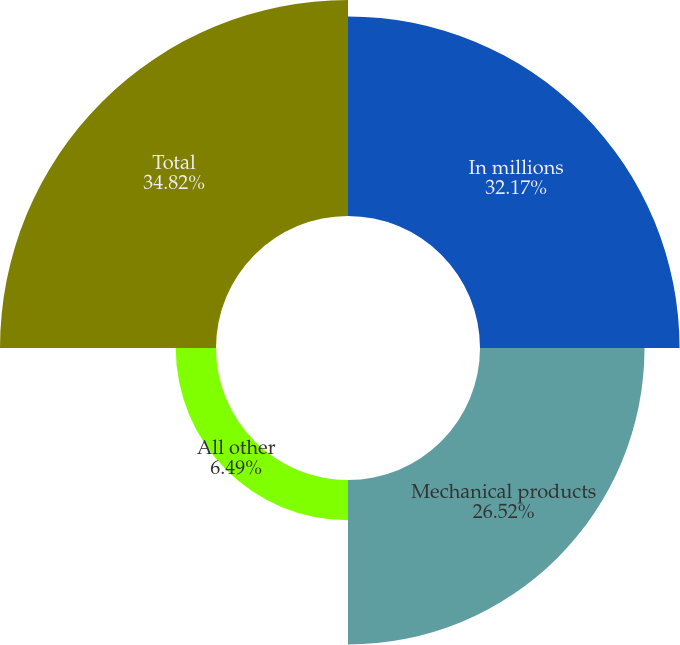Convert chart. <chart><loc_0><loc_0><loc_500><loc_500><pie_chart><fcel>In millions<fcel>Mechanical products<fcel>All other<fcel>Total<nl><fcel>32.17%<fcel>26.52%<fcel>6.49%<fcel>34.82%<nl></chart> 